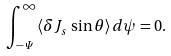<formula> <loc_0><loc_0><loc_500><loc_500>\int _ { - { \mathit \Psi } } ^ { \infty } \langle \delta J _ { s } \, \sin \theta \rangle \, d \psi = 0 .</formula> 